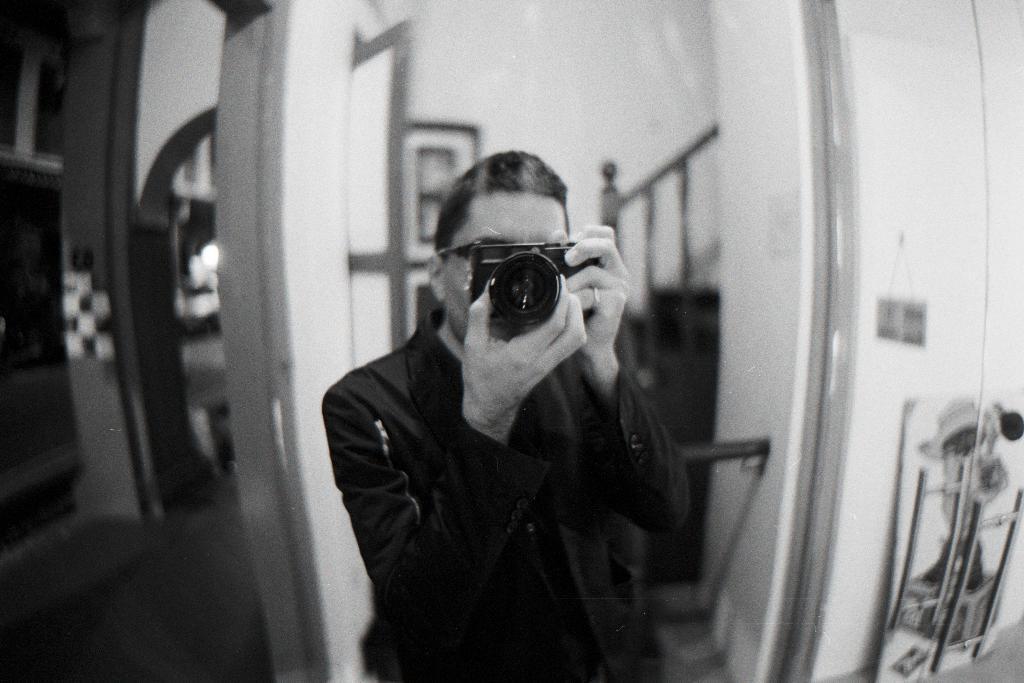In one or two sentences, can you explain what this image depicts? In this picture one person is standing and he is holding a camera to take the picture back side is look like house. 